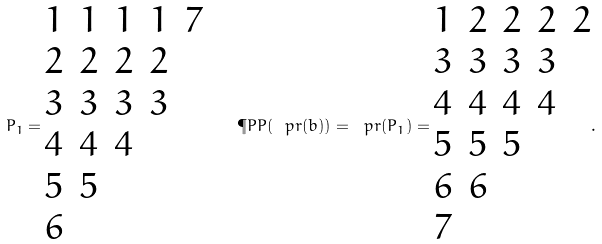<formula> <loc_0><loc_0><loc_500><loc_500>P _ { 1 } = \begin{matrix} 1 & 1 & 1 & 1 & 7 \\ 2 & 2 & 2 & 2 \\ 3 & 3 & 3 & 3 \\ 4 & 4 & 4 & \\ 5 & 5 & & \\ 6 & & & \\ \end{matrix} \quad \P P P ( \ p r ( b ) ) = \ p r ( P _ { 1 } ) = \begin{matrix} 1 & 2 & 2 & 2 & 2 \\ 3 & 3 & 3 & 3 & \\ 4 & 4 & 4 & 4 & \\ 5 & 5 & 5 & & \\ 6 & 6 & & & \\ 7 & & & & \end{matrix} .</formula> 